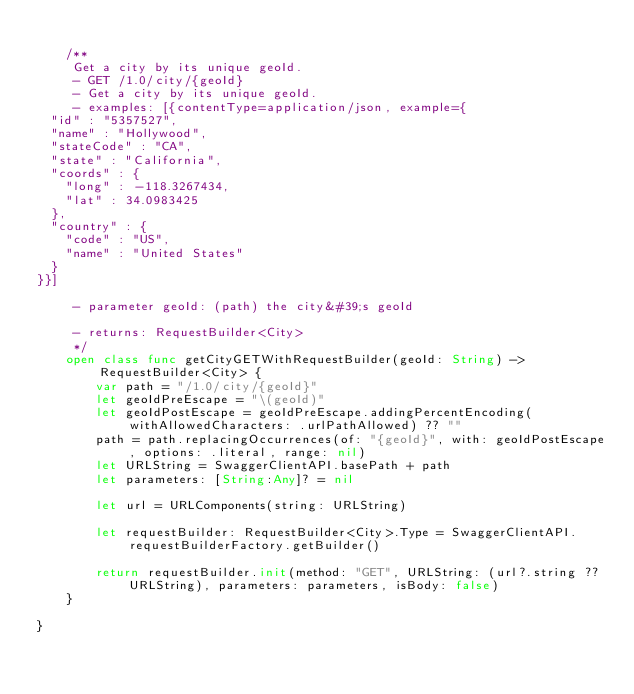Convert code to text. <code><loc_0><loc_0><loc_500><loc_500><_Swift_>
    /**
     Get a city by its unique geoId.
     - GET /1.0/city/{geoId}
     - Get a city by its unique geoId.
     - examples: [{contentType=application/json, example={
  "id" : "5357527",
  "name" : "Hollywood",
  "stateCode" : "CA",
  "state" : "California",
  "coords" : {
    "long" : -118.3267434,
    "lat" : 34.0983425
  },
  "country" : {
    "code" : "US",
    "name" : "United States"
  }
}}]
     
     - parameter geoId: (path) the city&#39;s geoId 

     - returns: RequestBuilder<City> 
     */
    open class func getCityGETWithRequestBuilder(geoId: String) -> RequestBuilder<City> {
        var path = "/1.0/city/{geoId}"
        let geoIdPreEscape = "\(geoId)"
        let geoIdPostEscape = geoIdPreEscape.addingPercentEncoding(withAllowedCharacters: .urlPathAllowed) ?? ""
        path = path.replacingOccurrences(of: "{geoId}", with: geoIdPostEscape, options: .literal, range: nil)
        let URLString = SwaggerClientAPI.basePath + path
        let parameters: [String:Any]? = nil
        
        let url = URLComponents(string: URLString)

        let requestBuilder: RequestBuilder<City>.Type = SwaggerClientAPI.requestBuilderFactory.getBuilder()

        return requestBuilder.init(method: "GET", URLString: (url?.string ?? URLString), parameters: parameters, isBody: false)
    }

}
</code> 